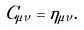Convert formula to latex. <formula><loc_0><loc_0><loc_500><loc_500>C _ { \mu \nu } = \eta _ { \mu \nu } .</formula> 